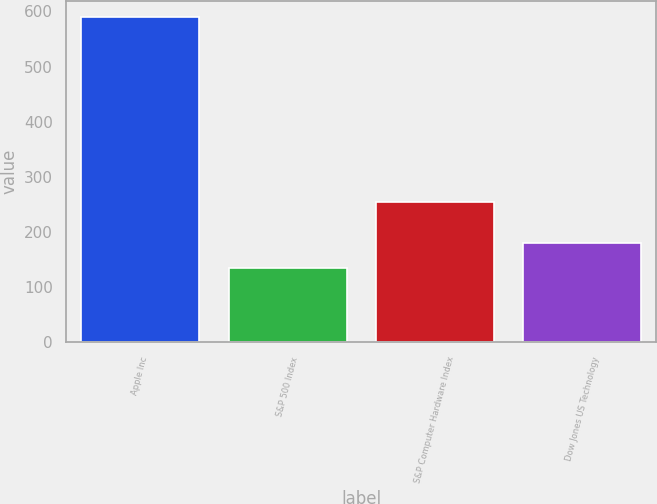Convert chart to OTSL. <chart><loc_0><loc_0><loc_500><loc_500><bar_chart><fcel>Apple Inc<fcel>S&P 500 Index<fcel>S&P Computer Hardware Index<fcel>Dow Jones US Technology<nl><fcel>589<fcel>135<fcel>255<fcel>180.4<nl></chart> 